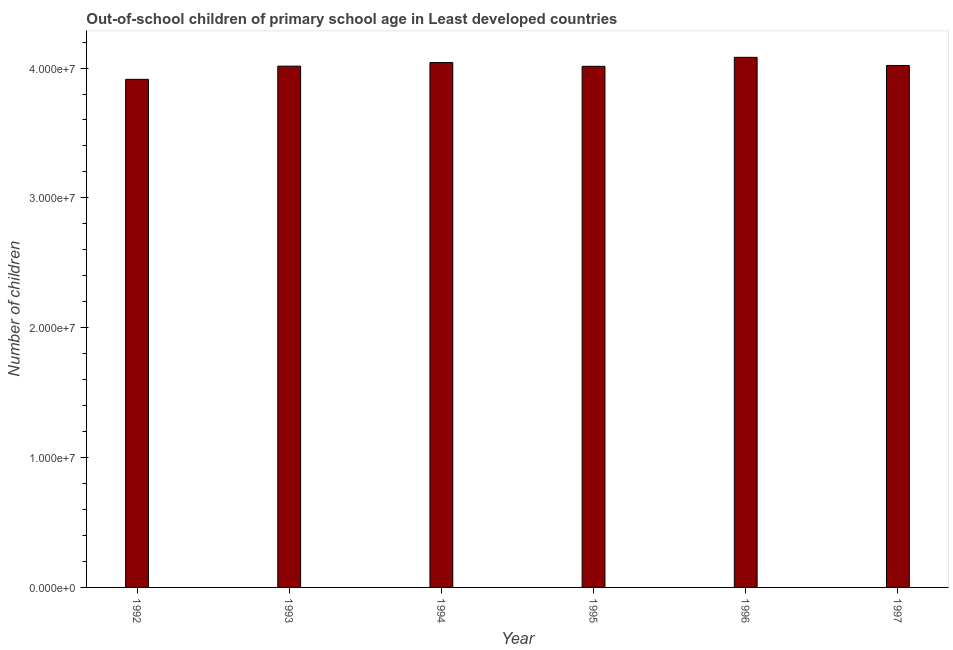What is the title of the graph?
Provide a succinct answer. Out-of-school children of primary school age in Least developed countries. What is the label or title of the Y-axis?
Keep it short and to the point. Number of children. What is the number of out-of-school children in 1996?
Offer a very short reply. 4.08e+07. Across all years, what is the maximum number of out-of-school children?
Provide a short and direct response. 4.08e+07. Across all years, what is the minimum number of out-of-school children?
Make the answer very short. 3.91e+07. In which year was the number of out-of-school children minimum?
Your answer should be very brief. 1992. What is the sum of the number of out-of-school children?
Your answer should be very brief. 2.41e+08. What is the difference between the number of out-of-school children in 1993 and 1994?
Make the answer very short. -2.75e+05. What is the average number of out-of-school children per year?
Ensure brevity in your answer.  4.01e+07. What is the median number of out-of-school children?
Provide a succinct answer. 4.02e+07. In how many years, is the number of out-of-school children greater than 34000000 ?
Give a very brief answer. 6. Do a majority of the years between 1993 and 1997 (inclusive) have number of out-of-school children greater than 18000000 ?
Make the answer very short. Yes. What is the difference between the highest and the second highest number of out-of-school children?
Provide a succinct answer. 4.04e+05. What is the difference between the highest and the lowest number of out-of-school children?
Make the answer very short. 1.69e+06. Are all the bars in the graph horizontal?
Your answer should be compact. No. How many years are there in the graph?
Provide a short and direct response. 6. What is the difference between two consecutive major ticks on the Y-axis?
Your answer should be very brief. 1.00e+07. Are the values on the major ticks of Y-axis written in scientific E-notation?
Keep it short and to the point. Yes. What is the Number of children in 1992?
Offer a terse response. 3.91e+07. What is the Number of children in 1993?
Your response must be concise. 4.01e+07. What is the Number of children of 1994?
Keep it short and to the point. 4.04e+07. What is the Number of children in 1995?
Give a very brief answer. 4.01e+07. What is the Number of children of 1996?
Make the answer very short. 4.08e+07. What is the Number of children of 1997?
Offer a very short reply. 4.02e+07. What is the difference between the Number of children in 1992 and 1993?
Your answer should be compact. -1.02e+06. What is the difference between the Number of children in 1992 and 1994?
Make the answer very short. -1.29e+06. What is the difference between the Number of children in 1992 and 1995?
Your answer should be compact. -1.00e+06. What is the difference between the Number of children in 1992 and 1996?
Keep it short and to the point. -1.69e+06. What is the difference between the Number of children in 1992 and 1997?
Keep it short and to the point. -1.07e+06. What is the difference between the Number of children in 1993 and 1994?
Provide a short and direct response. -2.75e+05. What is the difference between the Number of children in 1993 and 1995?
Your answer should be very brief. 1.39e+04. What is the difference between the Number of children in 1993 and 1996?
Offer a very short reply. -6.79e+05. What is the difference between the Number of children in 1993 and 1997?
Your answer should be compact. -5.14e+04. What is the difference between the Number of children in 1994 and 1995?
Make the answer very short. 2.89e+05. What is the difference between the Number of children in 1994 and 1996?
Give a very brief answer. -4.04e+05. What is the difference between the Number of children in 1994 and 1997?
Your response must be concise. 2.24e+05. What is the difference between the Number of children in 1995 and 1996?
Your response must be concise. -6.93e+05. What is the difference between the Number of children in 1995 and 1997?
Provide a short and direct response. -6.53e+04. What is the difference between the Number of children in 1996 and 1997?
Provide a short and direct response. 6.28e+05. What is the ratio of the Number of children in 1992 to that in 1993?
Make the answer very short. 0.97. What is the ratio of the Number of children in 1992 to that in 1996?
Your answer should be very brief. 0.96. What is the ratio of the Number of children in 1993 to that in 1995?
Offer a terse response. 1. What is the ratio of the Number of children in 1993 to that in 1996?
Your response must be concise. 0.98. What is the ratio of the Number of children in 1993 to that in 1997?
Keep it short and to the point. 1. What is the ratio of the Number of children in 1994 to that in 1995?
Your response must be concise. 1.01. What is the ratio of the Number of children in 1995 to that in 1996?
Offer a terse response. 0.98. What is the ratio of the Number of children in 1995 to that in 1997?
Provide a short and direct response. 1. What is the ratio of the Number of children in 1996 to that in 1997?
Provide a short and direct response. 1.02. 